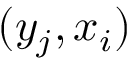Convert formula to latex. <formula><loc_0><loc_0><loc_500><loc_500>( y _ { j } , x _ { i } )</formula> 